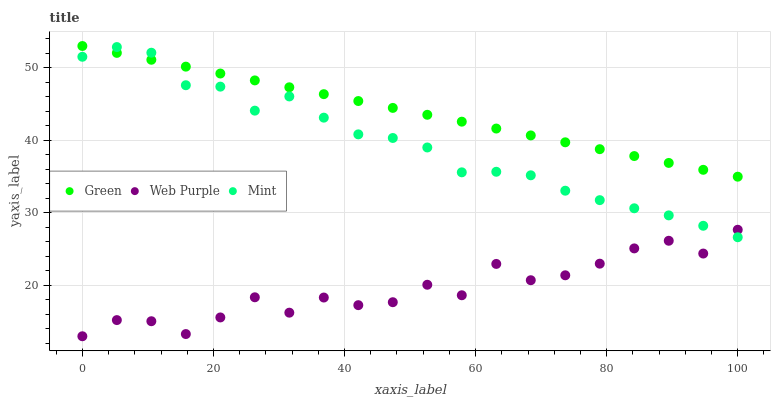Does Web Purple have the minimum area under the curve?
Answer yes or no. Yes. Does Green have the maximum area under the curve?
Answer yes or no. Yes. Does Green have the minimum area under the curve?
Answer yes or no. No. Does Web Purple have the maximum area under the curve?
Answer yes or no. No. Is Green the smoothest?
Answer yes or no. Yes. Is Web Purple the roughest?
Answer yes or no. Yes. Is Web Purple the smoothest?
Answer yes or no. No. Is Green the roughest?
Answer yes or no. No. Does Web Purple have the lowest value?
Answer yes or no. Yes. Does Green have the lowest value?
Answer yes or no. No. Does Green have the highest value?
Answer yes or no. Yes. Does Web Purple have the highest value?
Answer yes or no. No. Is Web Purple less than Green?
Answer yes or no. Yes. Is Green greater than Web Purple?
Answer yes or no. Yes. Does Web Purple intersect Mint?
Answer yes or no. Yes. Is Web Purple less than Mint?
Answer yes or no. No. Is Web Purple greater than Mint?
Answer yes or no. No. Does Web Purple intersect Green?
Answer yes or no. No. 